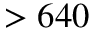<formula> <loc_0><loc_0><loc_500><loc_500>> 6 4 0</formula> 